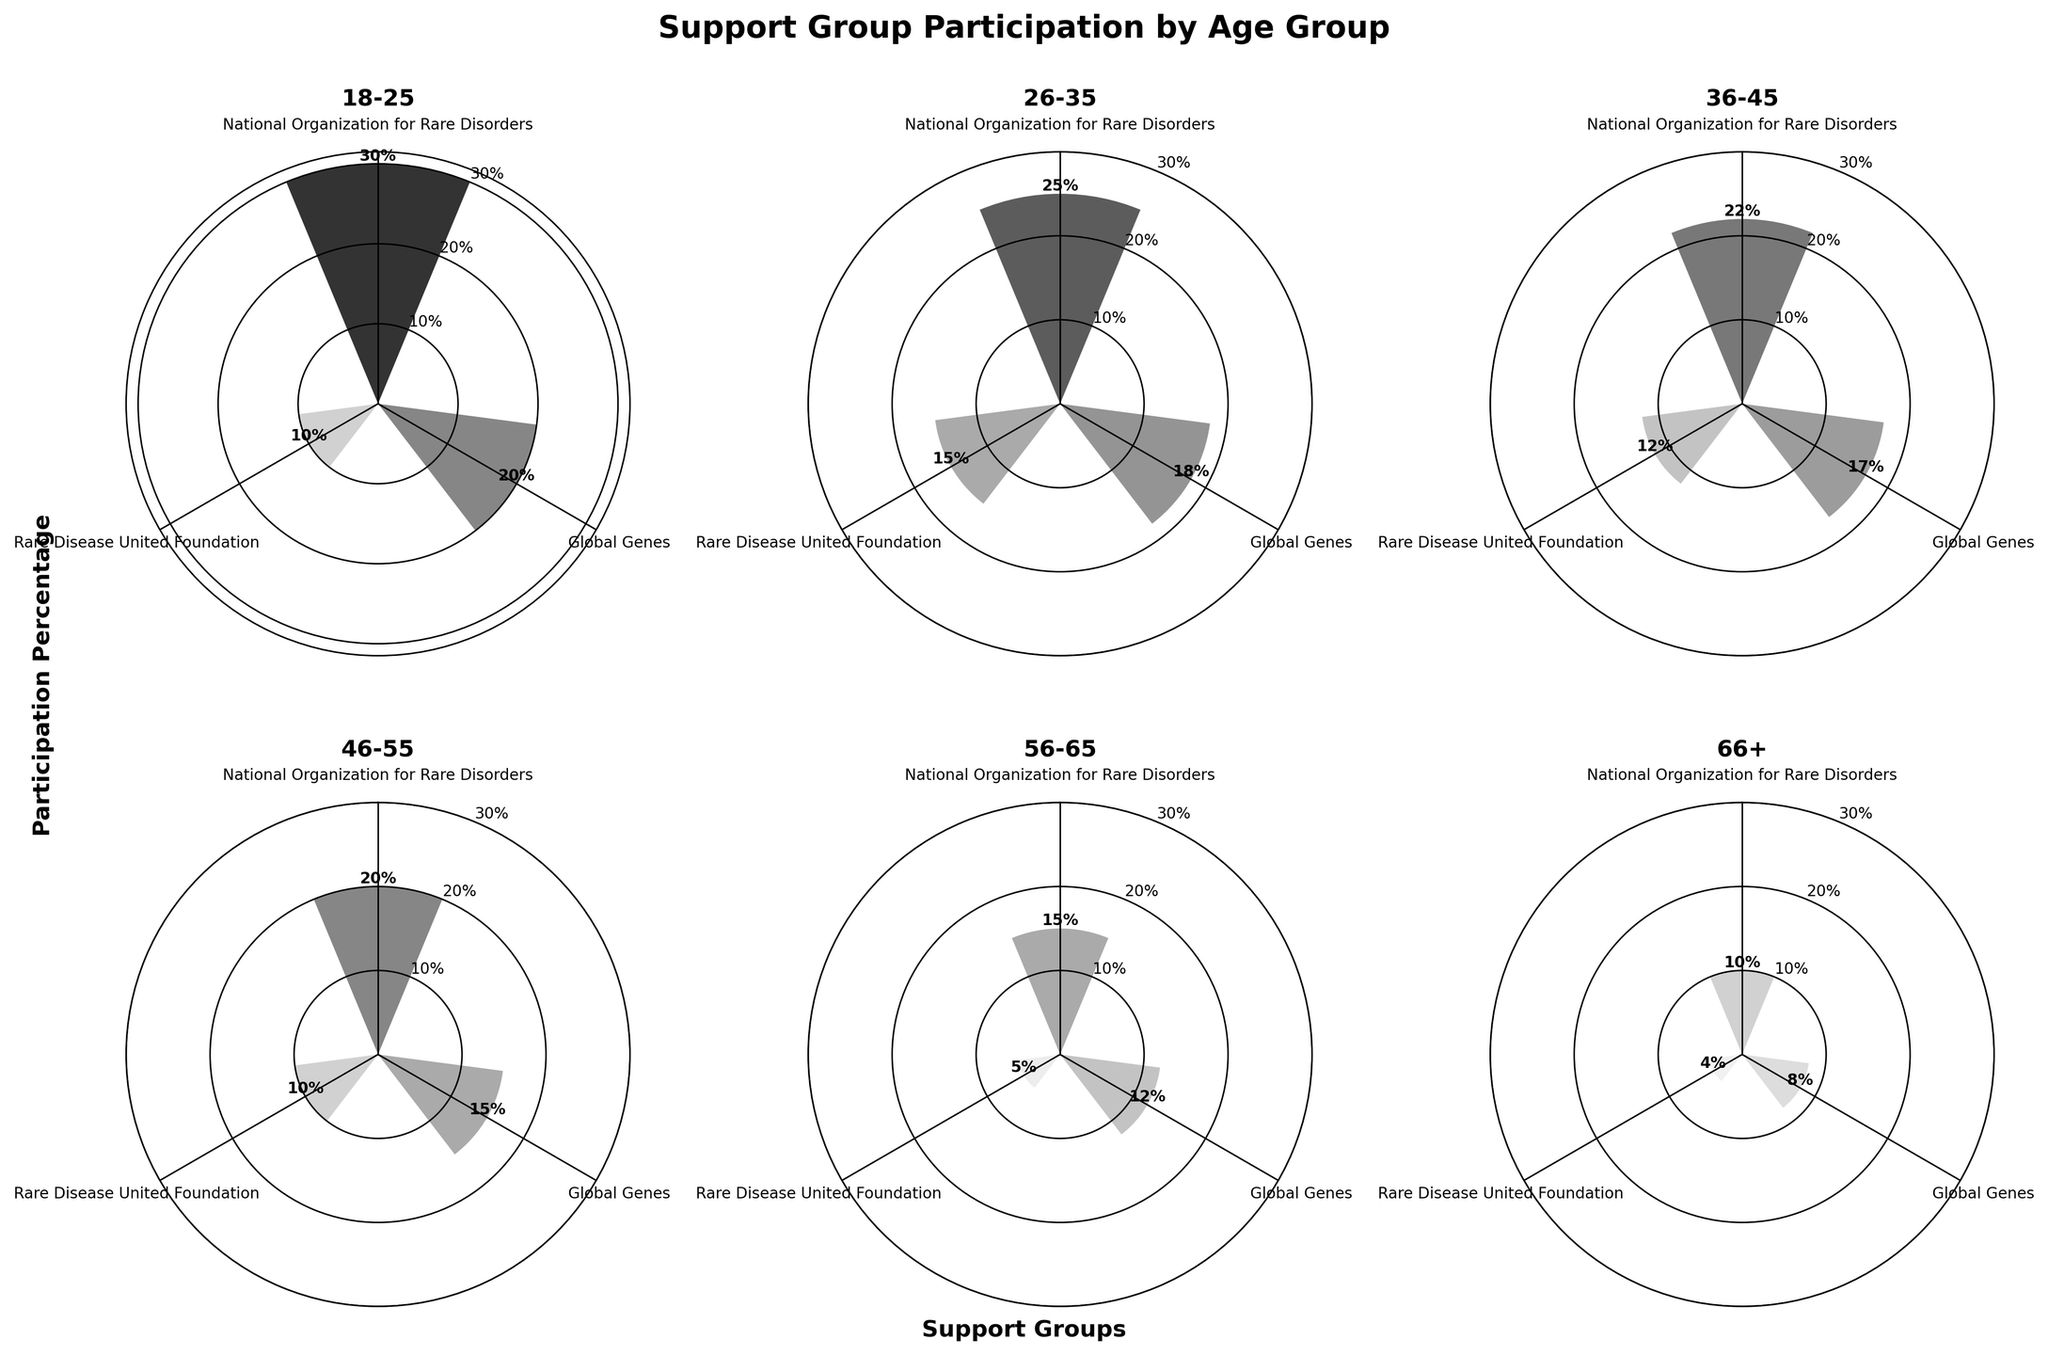What is the title of the figure? The title of the figure is displayed at the top and reads "Support Group Participation by Age Group".
Answer: Support Group Participation by Age Group Which age group has the highest participation percentage for the National Organization for Rare Disorders? By looking at the rose chart for each age group and examining the segment representing the National Organization for Rare Disorders, the largest segment is in the 18-25 age group with 30% participation.
Answer: 18-25 How does the participation percentage for Global Genes compare between the 26-35 and 36-45 age groups? The segments for Global Genes in the 26-35 and 36-45 age groups are 18% and 17%, respectively. Therefore, the 26-35 age group has a slightly higher participation percentage.
Answer: 26-35 age group has a higher percentage What is the combined participation percentage for the National Organization for Rare Disorders and Rare Disease United Foundation in the 56-65 age group? The segments for the National Organization for Rare Disorders and Rare Disease United Foundation in the 56-65 age group are 15% and 5%, respectively. Their combined participation is 15% + 5% = 20%.
Answer: 20% Which support group has the lowest participation percentage in the 66+ age group? By examining the segments in the rose chart for the 66+ age group, the smallest segment belongs to the Rare Disease United Foundation, which has a participation percentage of 4%.
Answer: Rare Disease United Foundation What is the average participation percentage for the three support groups in the 46-55 age group? The segments for the National Organization for Rare Disorders, Global Genes, and Rare Disease United Foundation in the 46-55 age group are 20%, 15%, and 10%, respectively. The average participation percentage is calculated as (20% + 15% + 10%) / 3 = 15%.
Answer: 15% In which age group is the participation for Rare Disease United Foundation the highest? By looking at the segments for Rare Disease United Foundation across all age groups, the highest percentage is found in the 26-35 age group with 15%.
Answer: 26-35 If the total population of 36-45 age group is 1,000, how many people participate in Global Genes within this age group? The 36-45 age group has a Global Genes participation percentage of 17%. Therefore, the number of people participating is 17% of 1,000, which is 0.17 * 1000 = 170 people.
Answer: 170 people Which age group has the most even distribution of participation percentages across the three support groups? By examining the segments in each rose chart, the 36-45 age group appears to have the most even distribution, with participation percentages of 22%, 17%, and 12%.
Answer: 36-45 